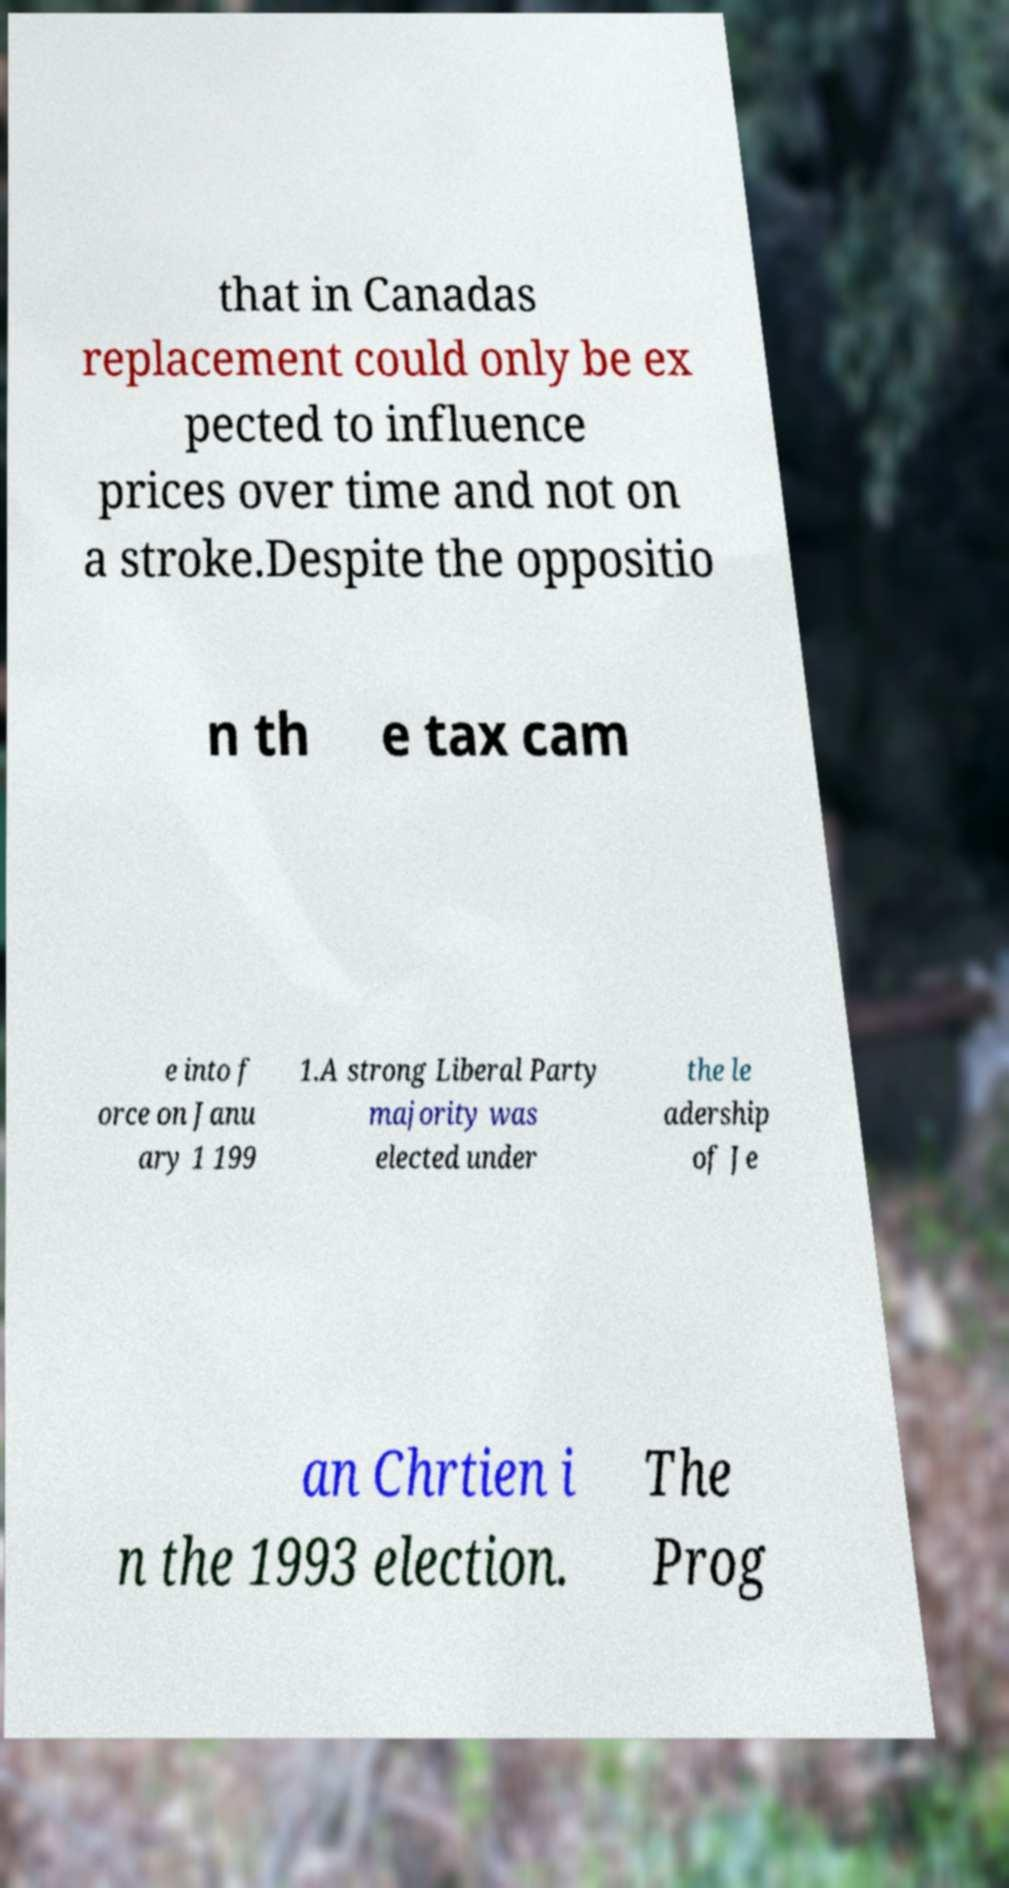There's text embedded in this image that I need extracted. Can you transcribe it verbatim? that in Canadas replacement could only be ex pected to influence prices over time and not on a stroke.Despite the oppositio n th e tax cam e into f orce on Janu ary 1 199 1.A strong Liberal Party majority was elected under the le adership of Je an Chrtien i n the 1993 election. The Prog 